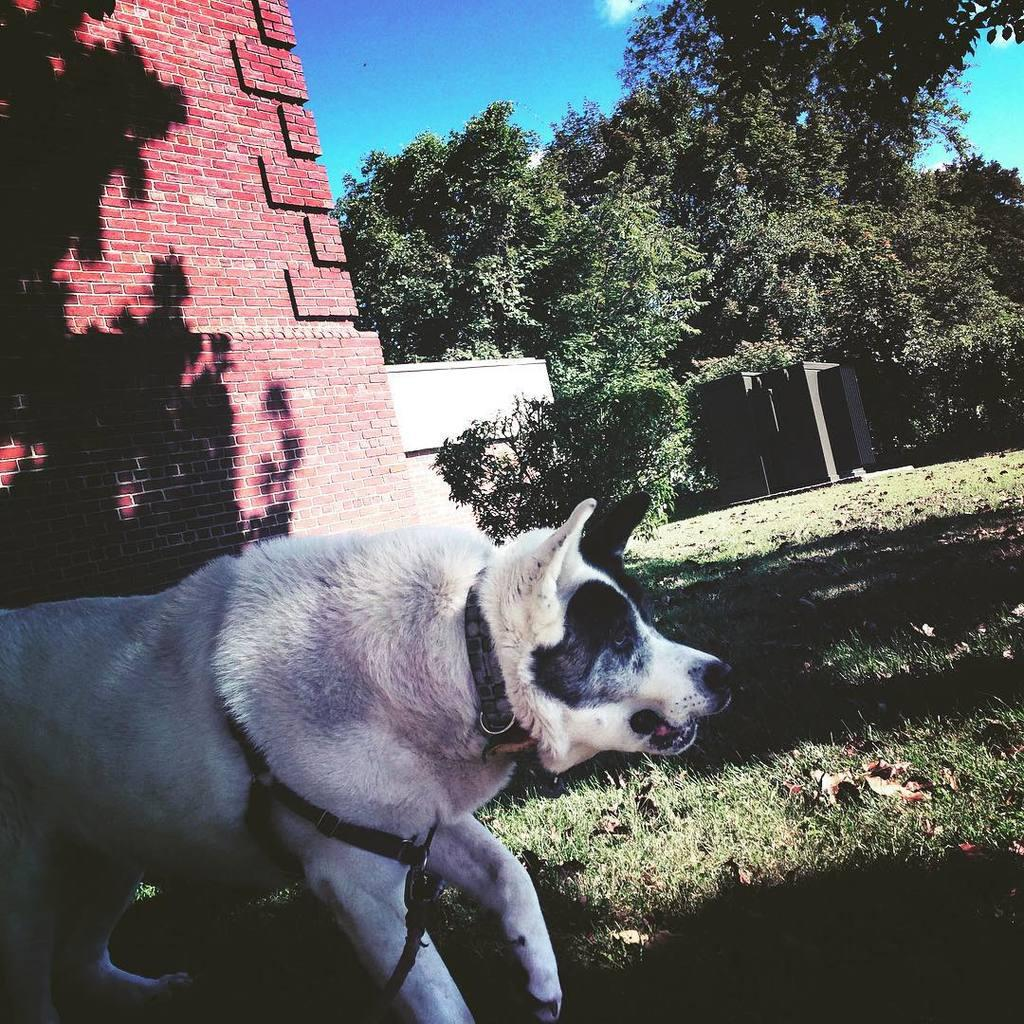What type of animal can be seen in the image? There is a dog in the image. What is the dog's position in relation to the ground? The dog is standing on the ground. What is the ground covered with? The ground is covered with grass. What can be seen in the background of the image? There are trees and a building made of red bricks visible in the background. What type of meal is the dog preparing in the image? There is no indication in the image that the dog is preparing a meal, as dogs do not typically cook or prepare food. 